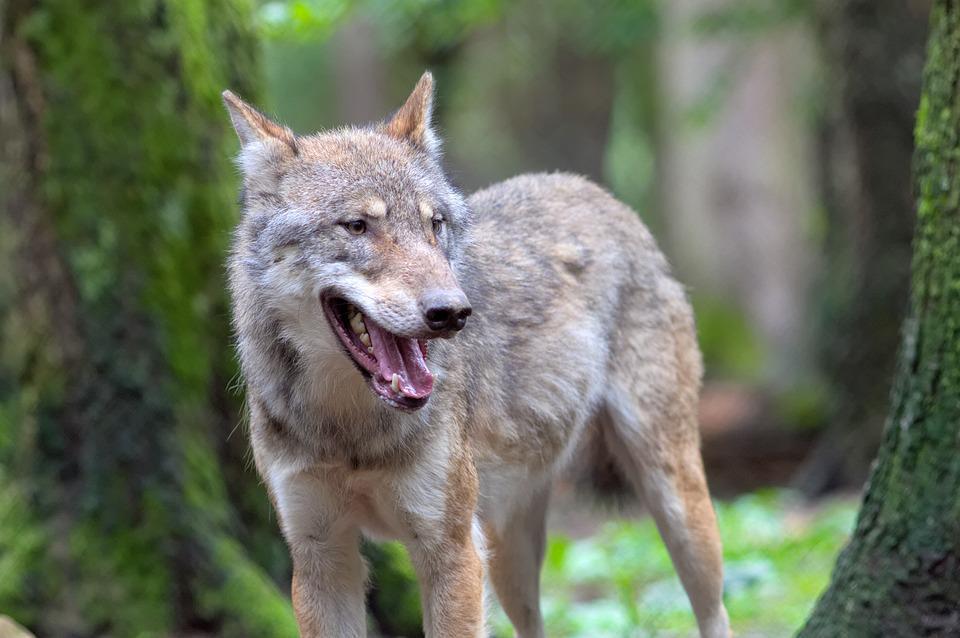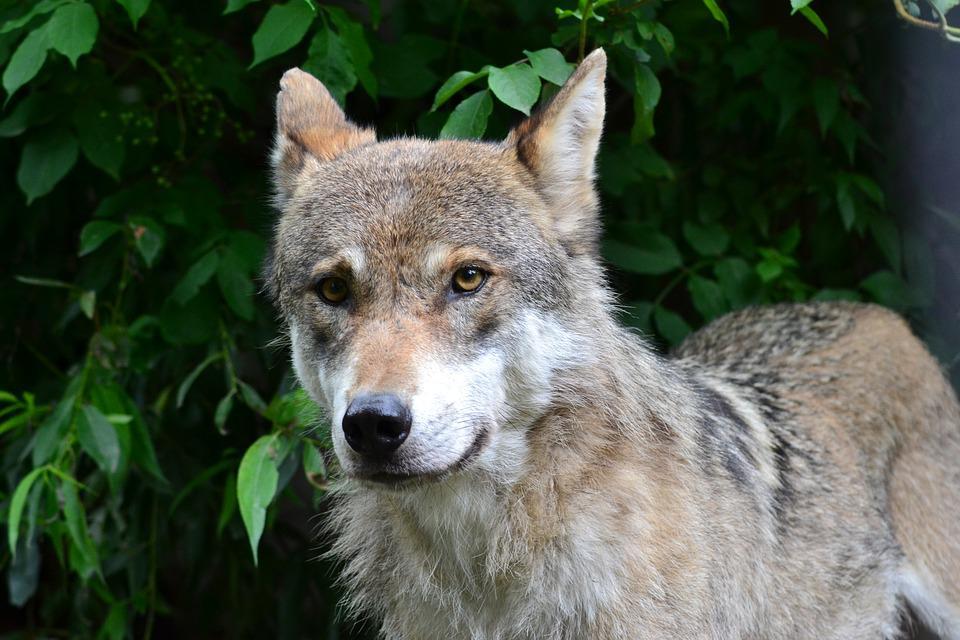The first image is the image on the left, the second image is the image on the right. Assess this claim about the two images: "A wolfs tongue is visible.". Correct or not? Answer yes or no. Yes. 